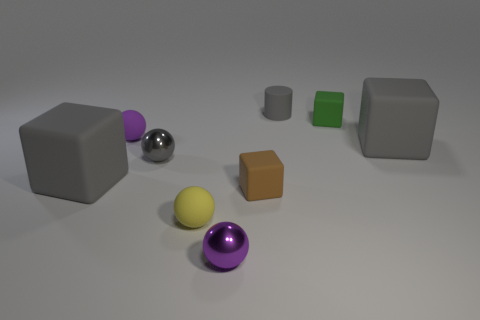What number of rubber things are small gray spheres or red things?
Ensure brevity in your answer.  0. How many metallic things have the same shape as the tiny gray rubber thing?
Your response must be concise. 0. Does the gray matte block on the right side of the brown block have the same size as the gray matte cube that is to the left of the tiny gray rubber cylinder?
Provide a succinct answer. Yes. There is a tiny matte thing that is behind the green matte block; what shape is it?
Keep it short and to the point. Cylinder. What material is the small yellow thing that is the same shape as the tiny purple metal object?
Your answer should be compact. Rubber. Does the brown rubber thing that is in front of the cylinder have the same size as the tiny gray metal sphere?
Ensure brevity in your answer.  Yes. What number of small things are in front of the tiny green rubber thing?
Your answer should be compact. 5. Are there fewer yellow rubber balls that are left of the yellow ball than green matte objects that are in front of the small cylinder?
Offer a terse response. Yes. What number of tiny gray metallic balls are there?
Offer a terse response. 1. There is a large cube that is on the left side of the tiny gray rubber cylinder; what color is it?
Make the answer very short. Gray. 